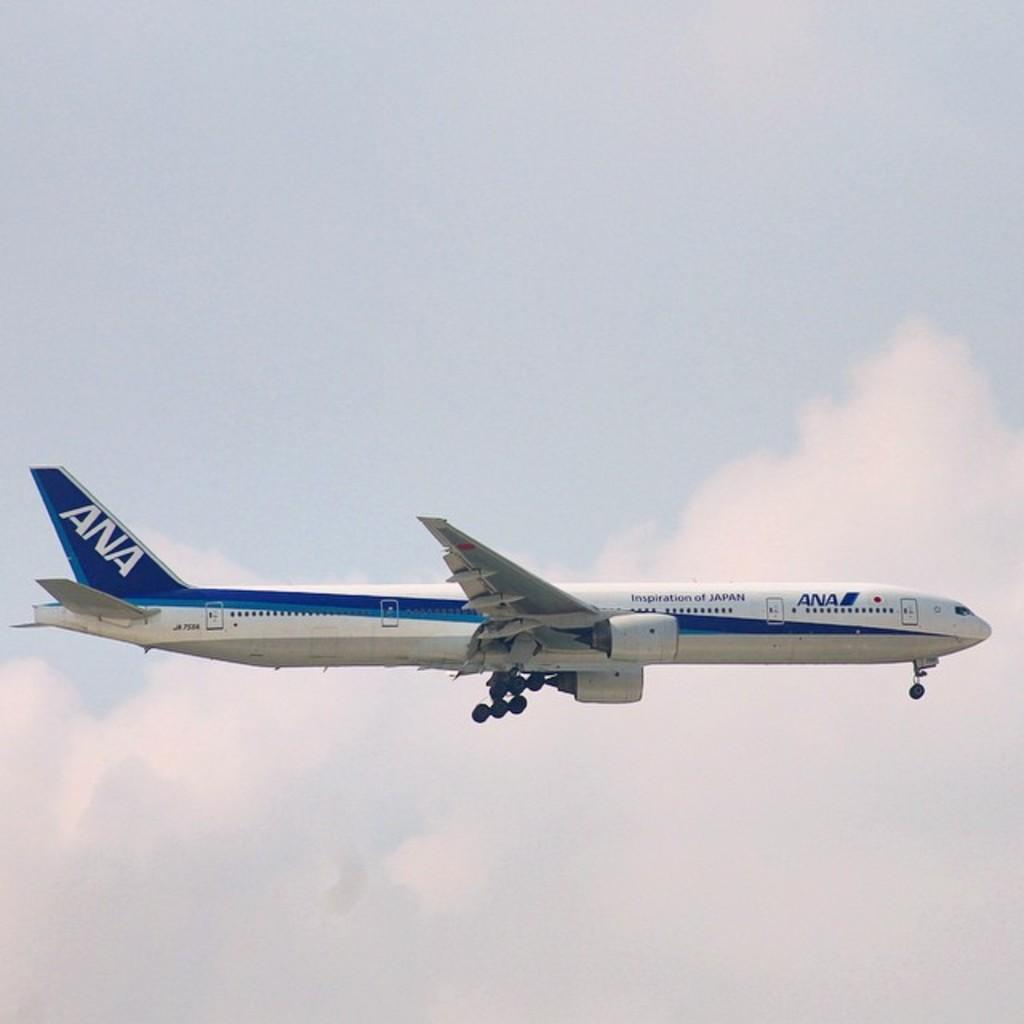<image>
Present a compact description of the photo's key features. A plane of ANA airline flying through the sky. 